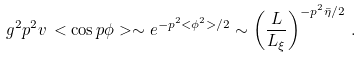Convert formula to latex. <formula><loc_0><loc_0><loc_500><loc_500>g ^ { 2 } p ^ { 2 } v \, < { \cos { p \phi } } > \sim e ^ { - p ^ { 2 } { < \phi ^ { 2 } > } / 2 } \sim \left ( \frac { L } { L _ { \xi } } \right ) ^ { - p ^ { 2 } \bar { \eta } / 2 } \, .</formula> 